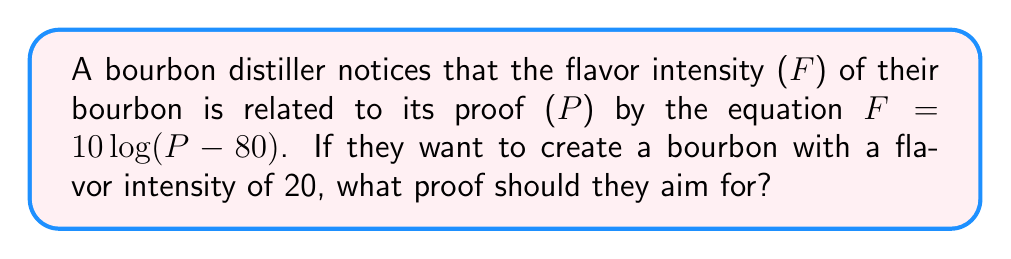What is the answer to this math problem? Let's approach this step-by-step:

1) We're given the equation: $F = 10 \log(P - 80)$

2) We want to find P when F = 20. Let's substitute this:

   $20 = 10 \log(P - 80)$

3) Divide both sides by 10:

   $2 = \log(P - 80)$

4) To solve for P, we need to apply the inverse function of log, which is the exponential function:

   $e^2 = P - 80$

5) Calculate $e^2$:

   $e^2 \approx 7.389$

6) Now we can solve for P:

   $P = 7.389 + 80 = 87.389$

7) Since proof is typically expressed as a whole number, we round to the nearest integer:

   $P \approx 87$

Therefore, the distiller should aim for a proof of 87 to achieve a flavor intensity of 20.
Answer: 87 proof 